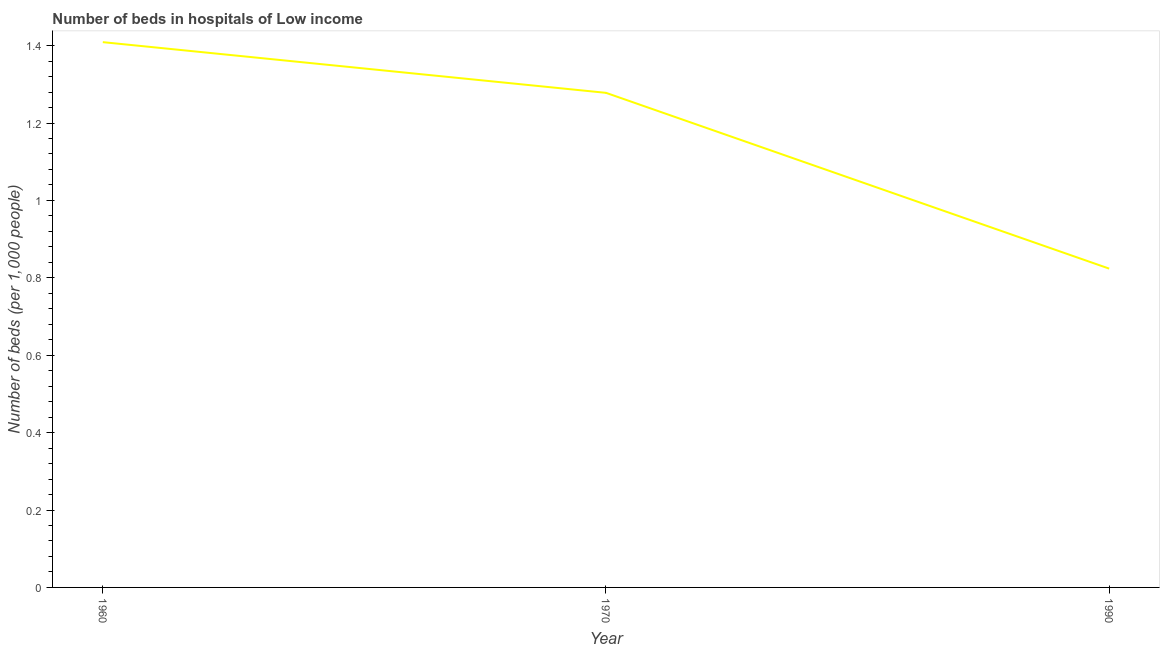What is the number of hospital beds in 1990?
Provide a short and direct response. 0.82. Across all years, what is the maximum number of hospital beds?
Offer a very short reply. 1.41. Across all years, what is the minimum number of hospital beds?
Your answer should be very brief. 0.82. In which year was the number of hospital beds minimum?
Offer a terse response. 1990. What is the sum of the number of hospital beds?
Provide a succinct answer. 3.51. What is the difference between the number of hospital beds in 1970 and 1990?
Give a very brief answer. 0.45. What is the average number of hospital beds per year?
Your response must be concise. 1.17. What is the median number of hospital beds?
Your answer should be compact. 1.28. In how many years, is the number of hospital beds greater than 0.6000000000000001 %?
Your answer should be very brief. 3. Do a majority of the years between 1990 and 1960 (inclusive) have number of hospital beds greater than 0.4 %?
Offer a very short reply. No. What is the ratio of the number of hospital beds in 1960 to that in 1970?
Offer a very short reply. 1.1. Is the difference between the number of hospital beds in 1970 and 1990 greater than the difference between any two years?
Offer a very short reply. No. What is the difference between the highest and the second highest number of hospital beds?
Make the answer very short. 0.13. Is the sum of the number of hospital beds in 1960 and 1970 greater than the maximum number of hospital beds across all years?
Your response must be concise. Yes. What is the difference between the highest and the lowest number of hospital beds?
Make the answer very short. 0.59. How many lines are there?
Make the answer very short. 1. How many years are there in the graph?
Your answer should be compact. 3. Are the values on the major ticks of Y-axis written in scientific E-notation?
Make the answer very short. No. Does the graph contain grids?
Give a very brief answer. No. What is the title of the graph?
Give a very brief answer. Number of beds in hospitals of Low income. What is the label or title of the Y-axis?
Your answer should be compact. Number of beds (per 1,0 people). What is the Number of beds (per 1,000 people) in 1960?
Your response must be concise. 1.41. What is the Number of beds (per 1,000 people) of 1970?
Your answer should be compact. 1.28. What is the Number of beds (per 1,000 people) of 1990?
Offer a terse response. 0.82. What is the difference between the Number of beds (per 1,000 people) in 1960 and 1970?
Make the answer very short. 0.13. What is the difference between the Number of beds (per 1,000 people) in 1960 and 1990?
Provide a succinct answer. 0.59. What is the difference between the Number of beds (per 1,000 people) in 1970 and 1990?
Give a very brief answer. 0.45. What is the ratio of the Number of beds (per 1,000 people) in 1960 to that in 1970?
Keep it short and to the point. 1.1. What is the ratio of the Number of beds (per 1,000 people) in 1960 to that in 1990?
Give a very brief answer. 1.71. What is the ratio of the Number of beds (per 1,000 people) in 1970 to that in 1990?
Offer a very short reply. 1.55. 